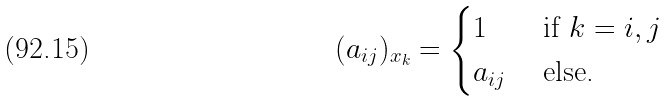<formula> <loc_0><loc_0><loc_500><loc_500>( a _ { i j } ) _ { x _ { k } } = \begin{cases} 1 & \text { if $k=i,j$} \\ a _ { i j } & \text { else.} \end{cases}</formula> 